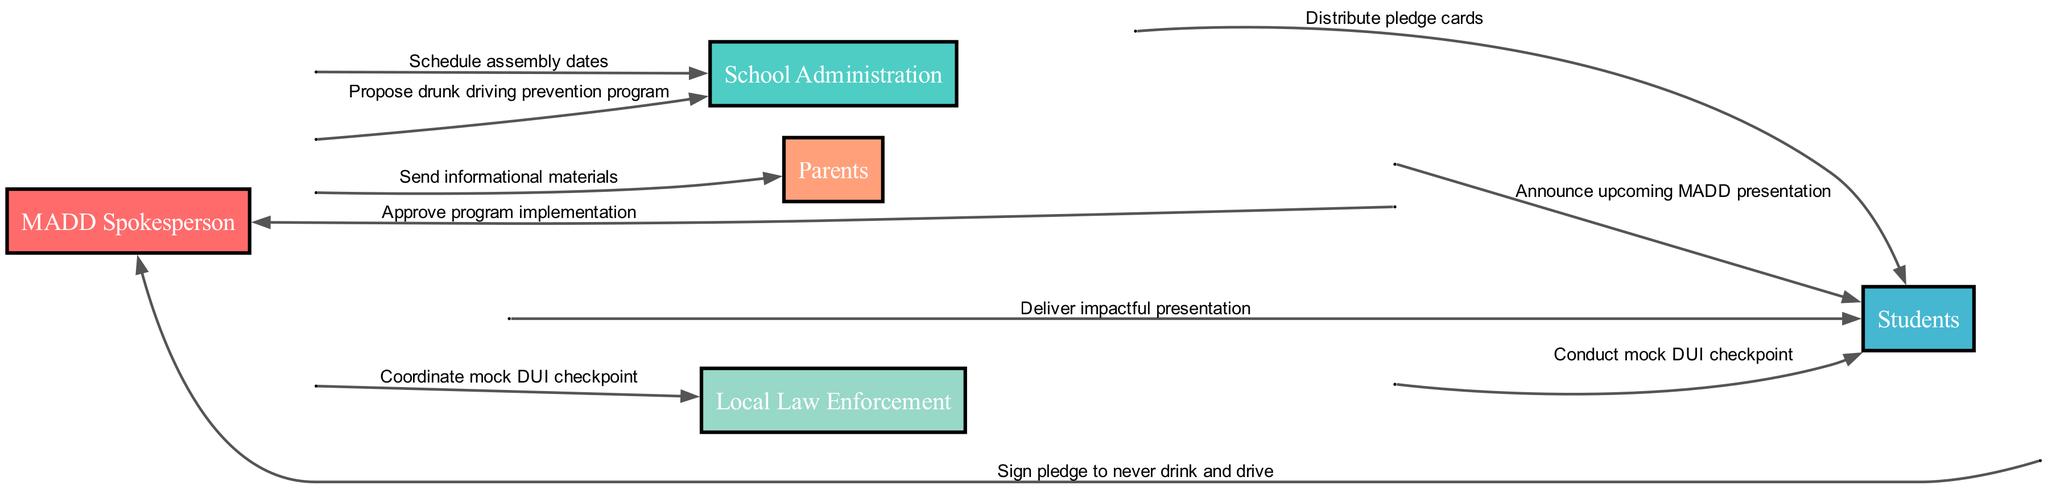What is the first action in the sequence? The diagram indicates that the first action is taken by the MADD Spokesperson proposing the drunk driving prevention program to the School Administration. This is the starting point of the sequence.
Answer: Propose drunk driving prevention program How many actors are involved in the sequence? By counting the distinct entities listed as actors in the diagram, we identify five key participants: MADD Spokesperson, School Administration, Students, Parents, and Local Law Enforcement. Therefore, the total number of actors is five.
Answer: 5 What action occurs after the School Administration approves the program? The sequence shows that once the School Administration approves the program implementation, the next action is for the MADD Spokesperson to schedule assembly dates, which follows directly from the approval.
Answer: Schedule assembly dates Which actor is responsible for conducting the mock DUI checkpoint? According to the diagram, the Local Law Enforcement is the actor tasked with conducting the mock DUI checkpoint, which occurs after coordination with the MADD Spokesperson.
Answer: Local Law Enforcement How many total actions are performed by the MADD Spokesperson in the sequence? By analyzing the sequence, we can see that the MADD Spokesperson performs four distinct actions: proposing the program, scheduling assembly dates, sending informational materials, and coordinating the mock DUI checkpoint. Therefore, the total number of actions is four.
Answer: 4 Which actors interact with the Students? The diagram reveals that the Students interact with three actors: the School Administration, the MADD Spokesperson, and the Local Law Enforcement. Each actor has distinct varying actions directed towards the Students, indicating their involvement in the program.
Answer: School Administration, MADD Spokesperson, Local Law Enforcement What is the final action of the sequence? The sequence concludes with the Students signing a pledge to never drink and drive, marking the last engagement in the process outlined in the diagram.
Answer: Sign pledge to never drink and drive What is the relationship between the MADD Spokesperson and the Parents? The MADD Spokesperson sends informational materials to the Parents, demonstrating a communication relationship focused on sharing knowledge and raising awareness about drunk driving.
Answer: Send informational materials Which action comes before the Students receive pledge cards? Reviewing the sequence reveals that the MADD Spokesperson delivers an impactful presentation to the Students before they receive the pledge cards. This presentation likely builds the context for the following action of signing pledges.
Answer: Deliver impactful presentation 